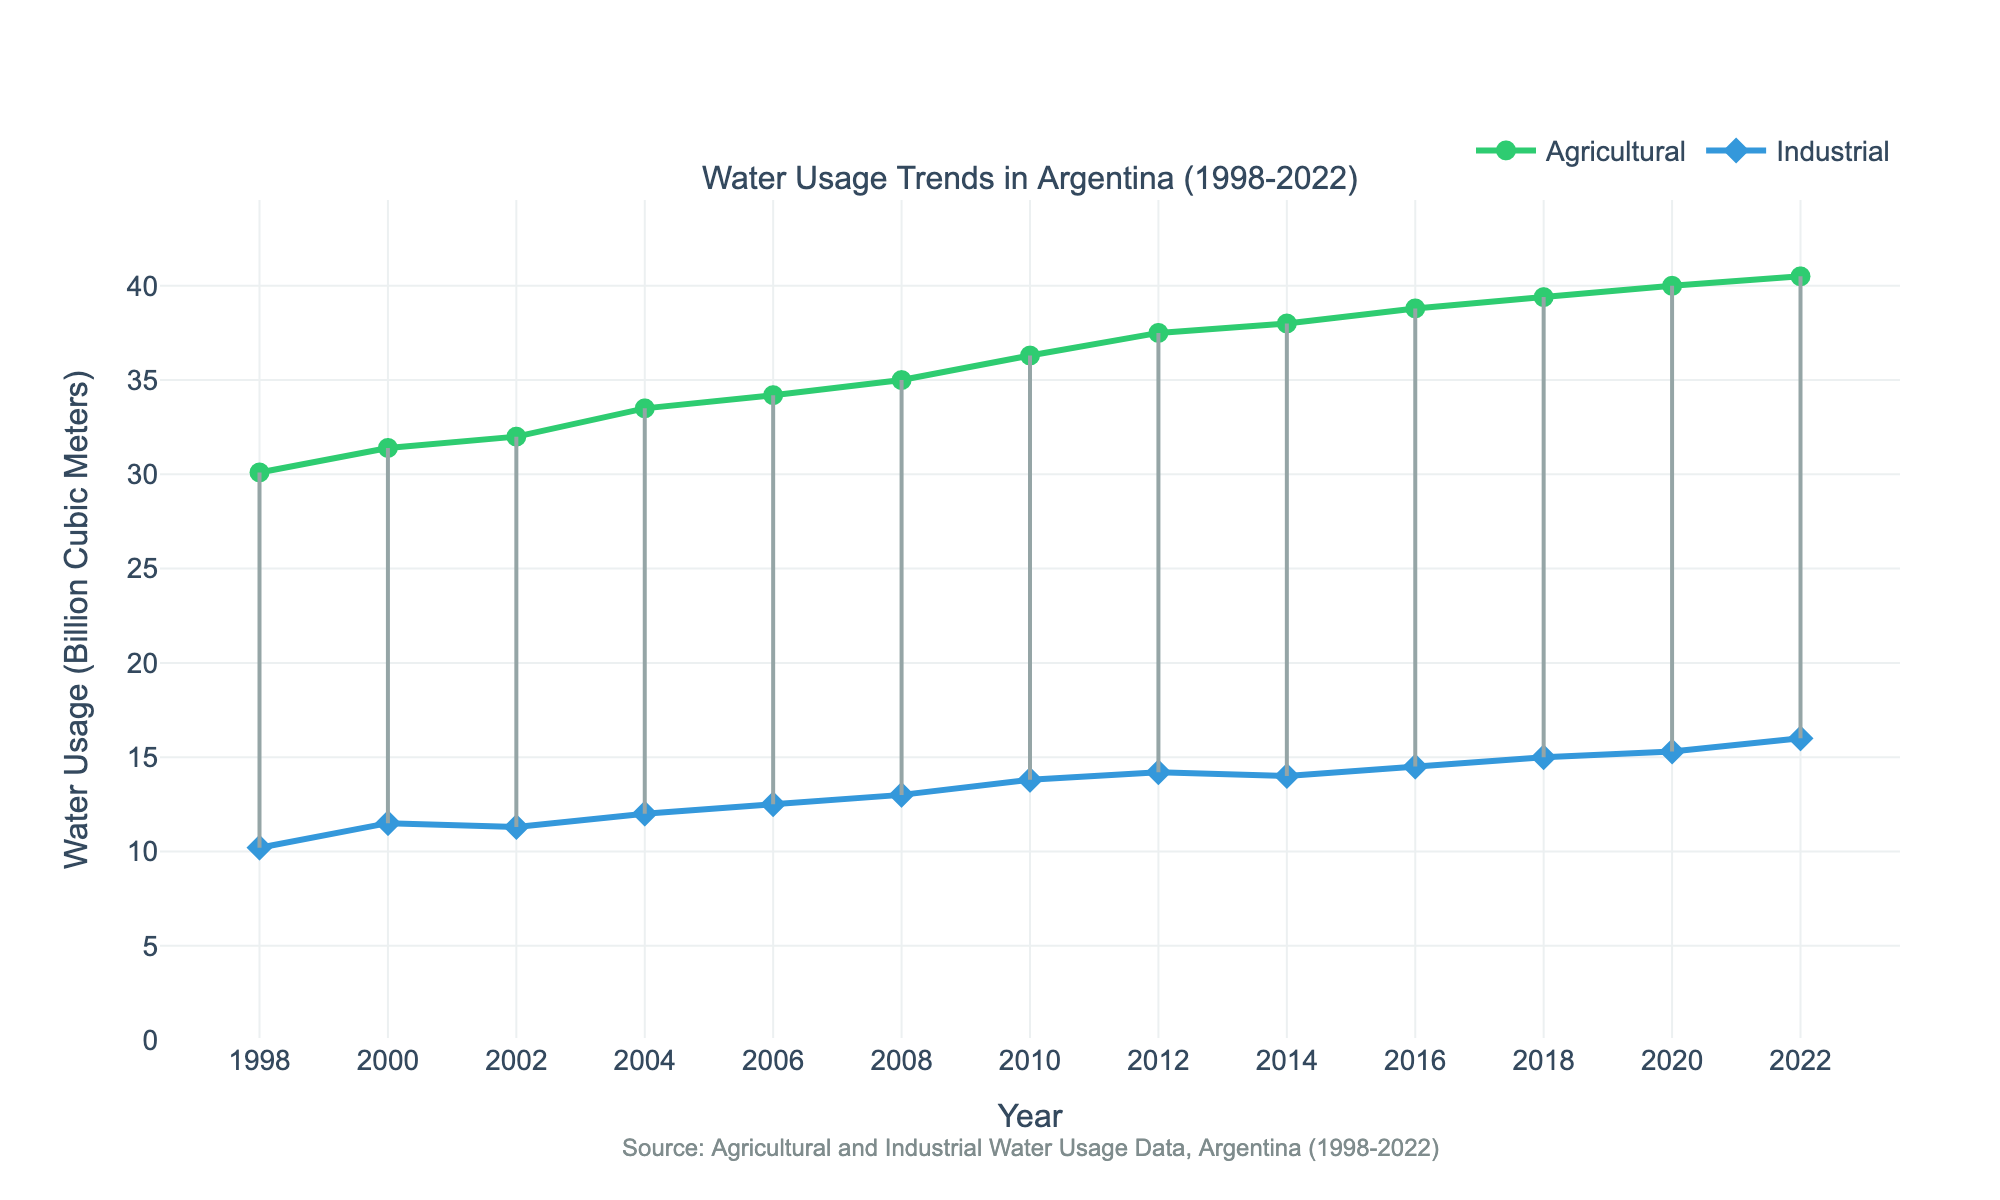What's the title of the plot? The title is usually found at the top center of the plot. In this case, it reads: "Water Usage Trends in Argentina (1998-2022)"
Answer: Water Usage Trends in Argentina (1998-2022) How many years of data are included in the plot? By counting the tick marks on the x-axis or the number of data points, we see that the years range from 1998 to 2022.
Answer: 25 years What colors are used to represent agricultural and industrial water usage? Agricultural water usage is represented in green, while industrial water usage is represented in blue. The plot legend or color of the line and markers indicate this.
Answer: Green for agricultural, blue for industrial What's the difference in agricultural water usage between the years 1998 and 2022? Agricultural water usage in 1998 is 30.1 billion cubic meters and in 2022 is 40.5 billion cubic meters. The difference is calculated by subtracting 30.1 from 40.5.
Answer: 10.4 billion cubic meters What was the trend in industrial water usage from 1998 to 2022? Observing the blue line and markers from 1998 to 2022, there's a steady increase, reflecting an upward trend in industrial water usage over these years.
Answer: Upward trend Which year had the highest agricultural water usage, and what was its value? The green line peaks at 2022, indicating the highest agricultural water usage of 40.5 billion cubic meters.
Answer: 2022, 40.5 billion cubic meters How does the gap between agricultural and industrial water usage change over time? By examining the dumbbells connecting the two lines, we observe that the gap increases gradually from 1998 to 2022, suggesting widening differences in usage over time.
Answer: Gradually increases What's the average water usage for industrial purposes over the entire period? Adding up all industrial water usage values and dividing by the number of data points (25). Sum = 10.2 + 11.5 + 11.3 + 12 + 12.5 + 13 + 13.8 + 14.2 + 14 + 14.5 + 15 + 15.3 + 16 = 172.3. Average = 172.3 / 13 = 13.25.
Answer: 13.25 billion cubic meters In which year was the smallest difference between agricultural and industrial water usage recorded? Checking the length of the dumbbells, the shortest line appears in 1998, indicating the smallest difference.
Answer: 1998 Is there any year where industrial water usage decreased compared to the previous year? Observing the blue line, we see no dips, indicating no instances where industrial water usage decreased year-over-year.
Answer: No 